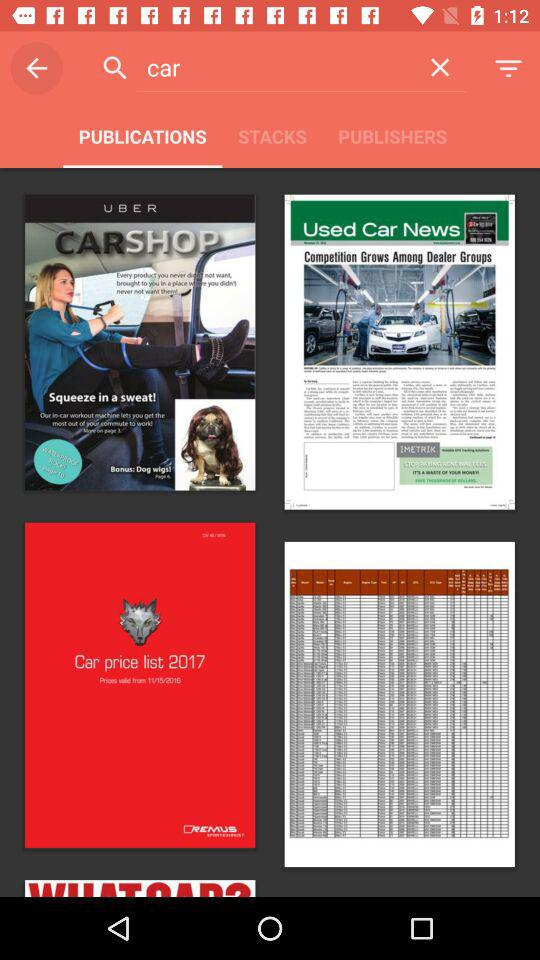Which tab is selected? The selected tab is "PUBLICATIONS". 